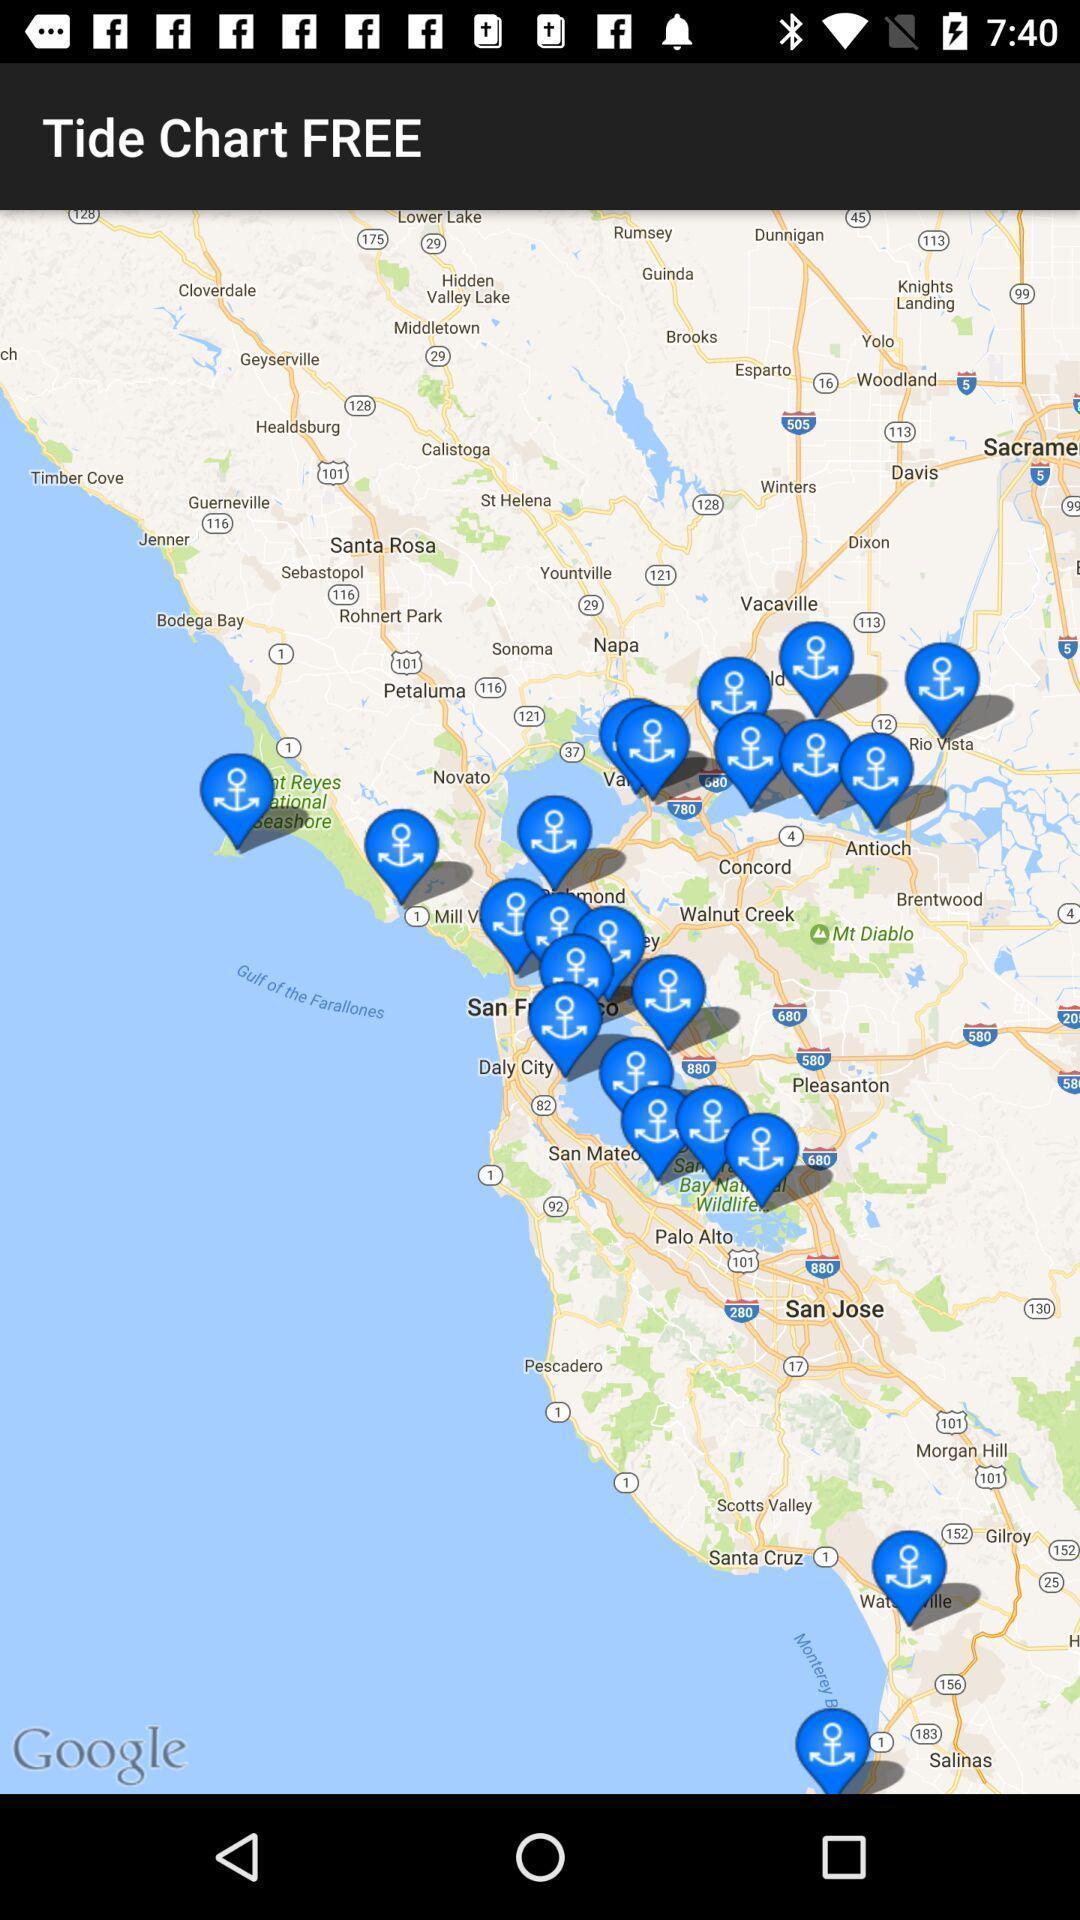Summarize the main components in this picture. Page showing different locations in map. 